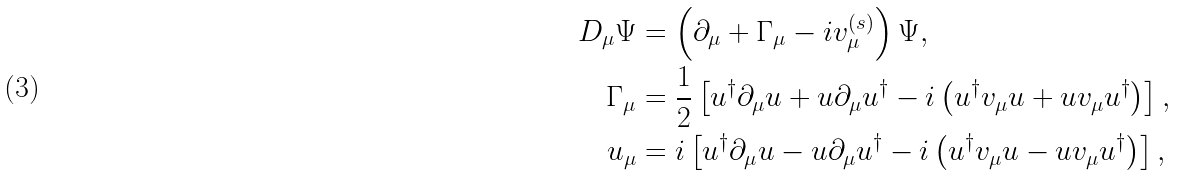Convert formula to latex. <formula><loc_0><loc_0><loc_500><loc_500>D _ { \mu } \Psi & = \left ( \partial _ { \mu } + \Gamma _ { \mu } - i v _ { \mu } ^ { ( s ) } \right ) \Psi , \\ \Gamma _ { \mu } & = \frac { 1 } { 2 } \left [ u ^ { \dagger } \partial _ { \mu } u + u \partial _ { \mu } u ^ { \dagger } - i \left ( u ^ { \dagger } v _ { \mu } u + u v _ { \mu } u ^ { \dagger } \right ) \right ] , \\ u _ { \mu } & = i \left [ u ^ { \dagger } \partial _ { \mu } u - u \partial _ { \mu } u ^ { \dagger } - i \left ( u ^ { \dagger } v _ { \mu } u - u v _ { \mu } u ^ { \dagger } \right ) \right ] ,</formula> 